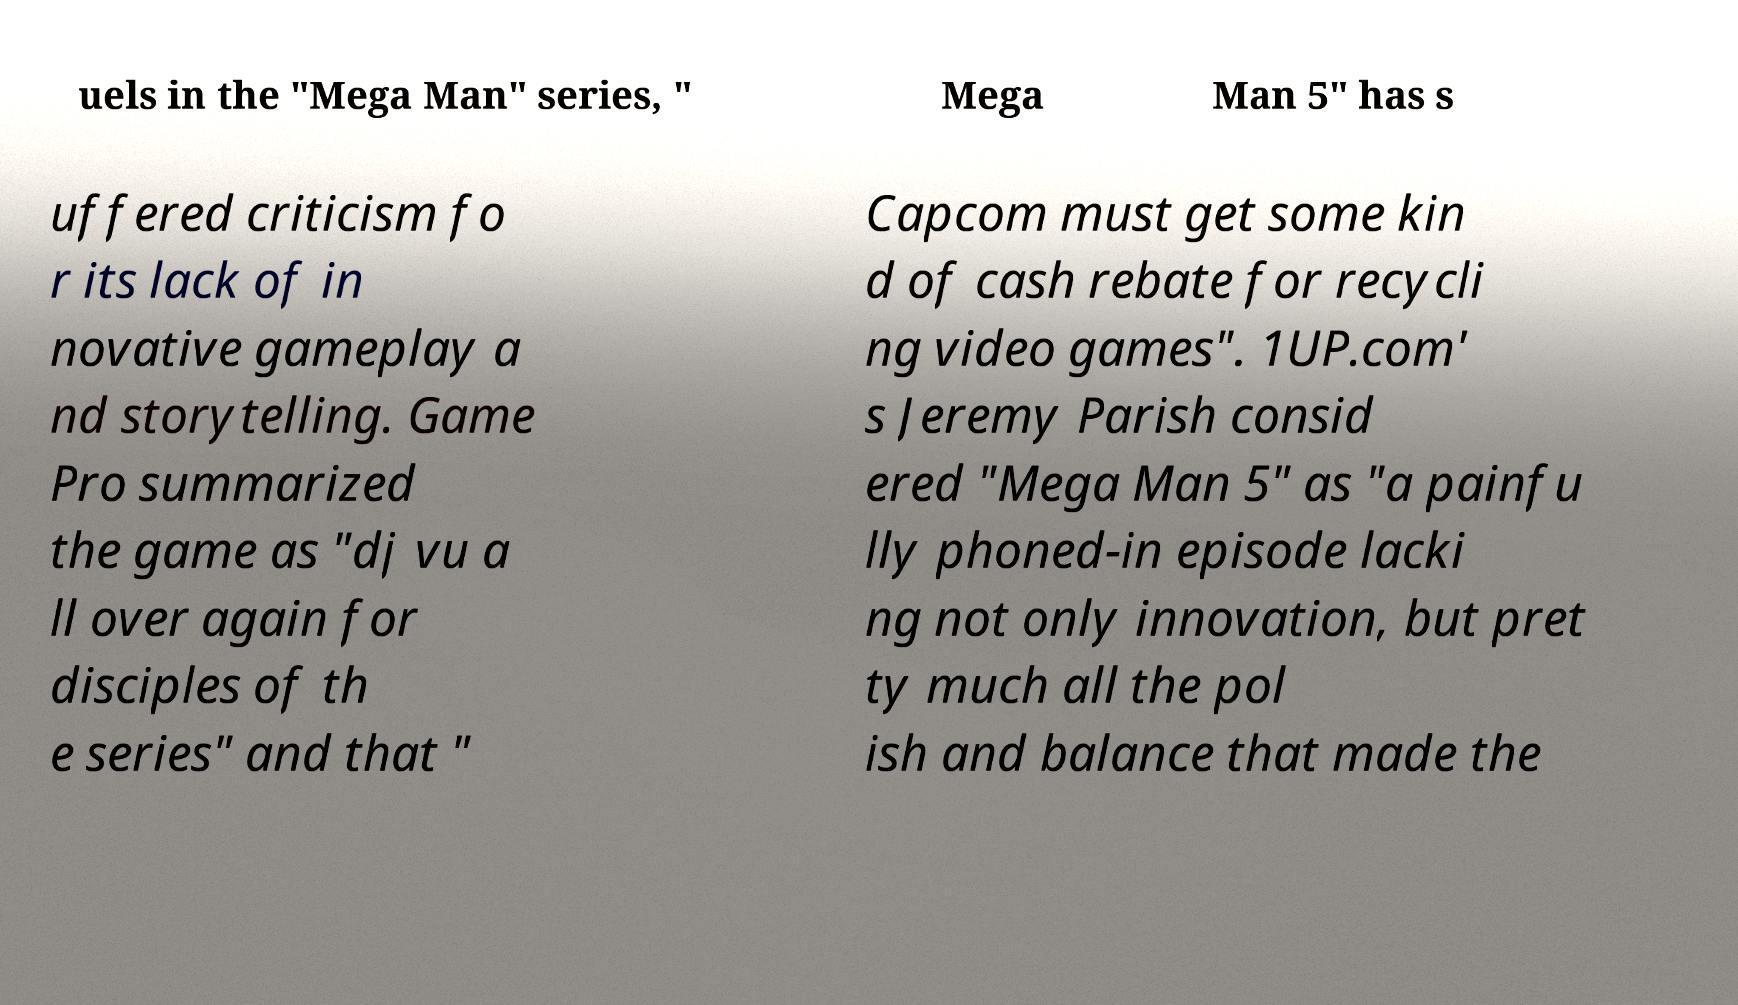Could you extract and type out the text from this image? uels in the "Mega Man" series, " Mega Man 5" has s uffered criticism fo r its lack of in novative gameplay a nd storytelling. Game Pro summarized the game as "dj vu a ll over again for disciples of th e series" and that " Capcom must get some kin d of cash rebate for recycli ng video games". 1UP.com' s Jeremy Parish consid ered "Mega Man 5" as "a painfu lly phoned-in episode lacki ng not only innovation, but pret ty much all the pol ish and balance that made the 